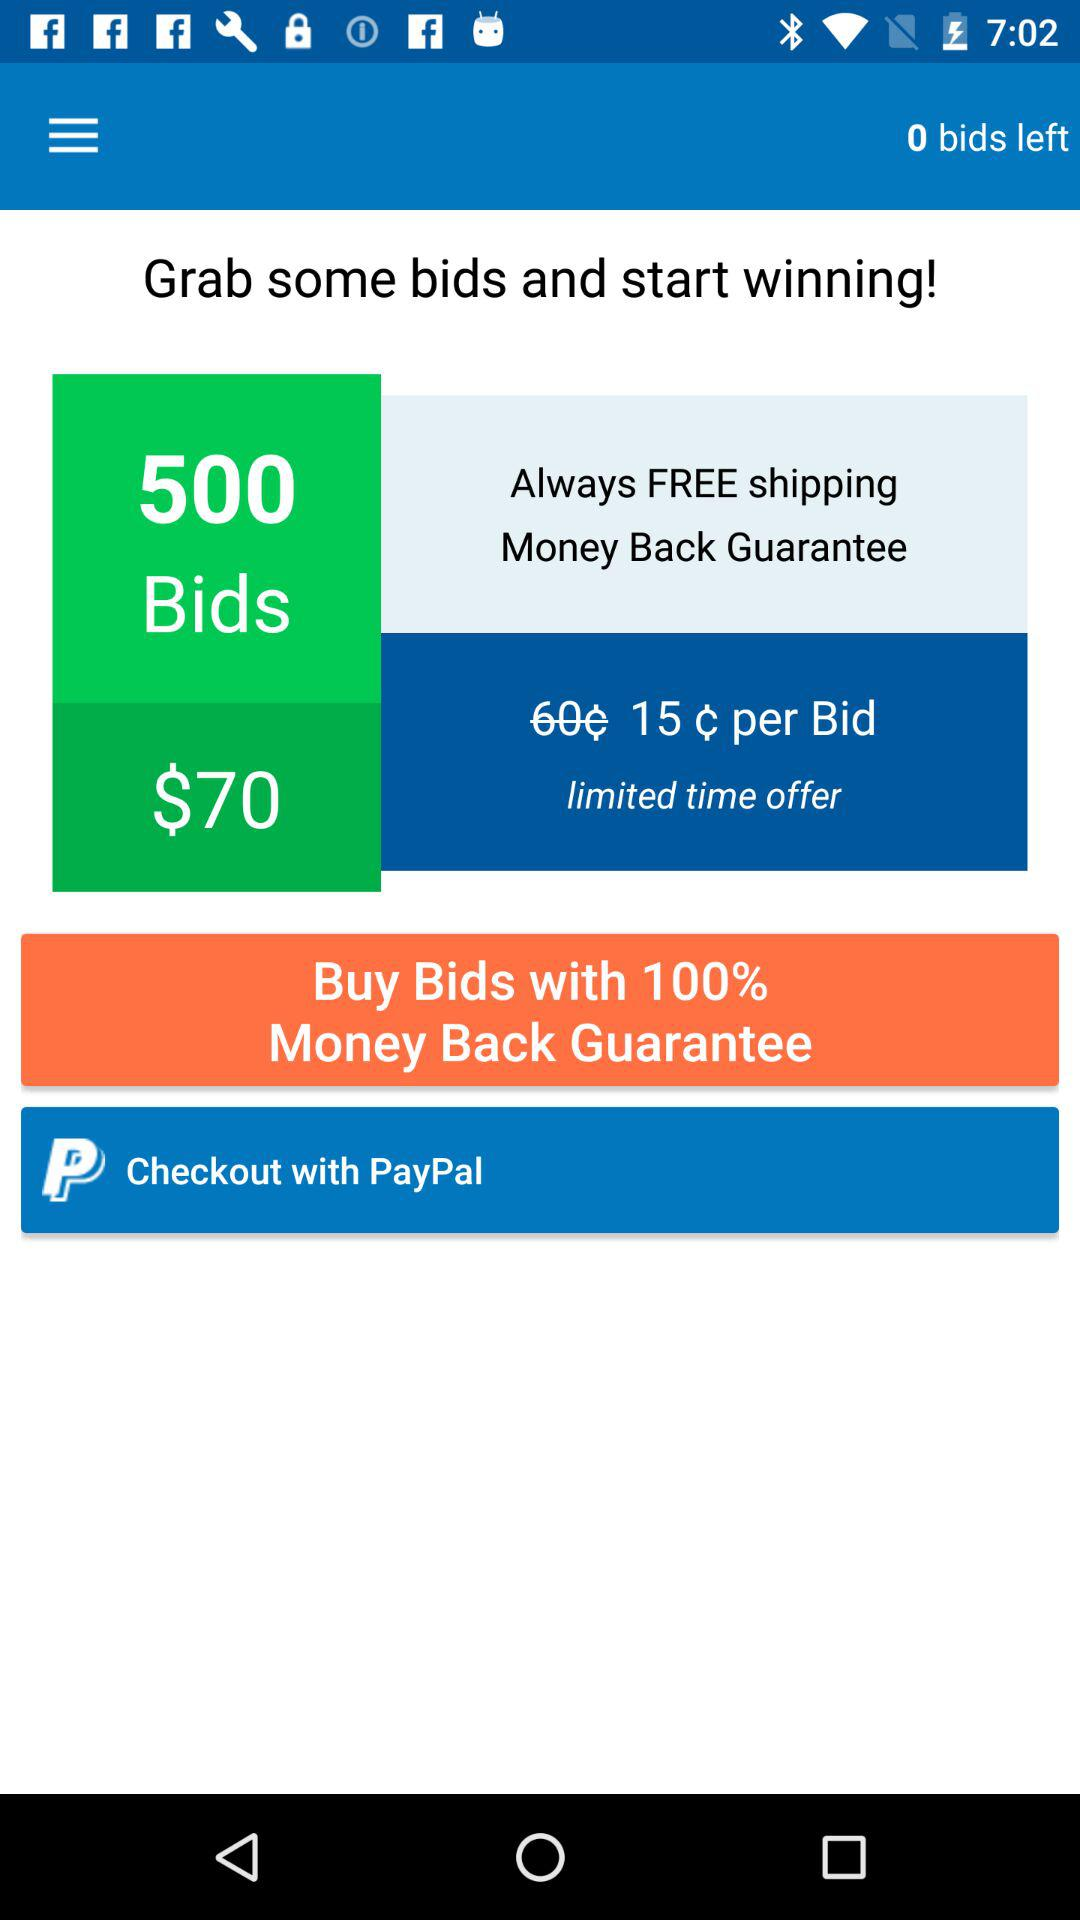What is the per-bid amount? The per-bid amount is ₵15. 